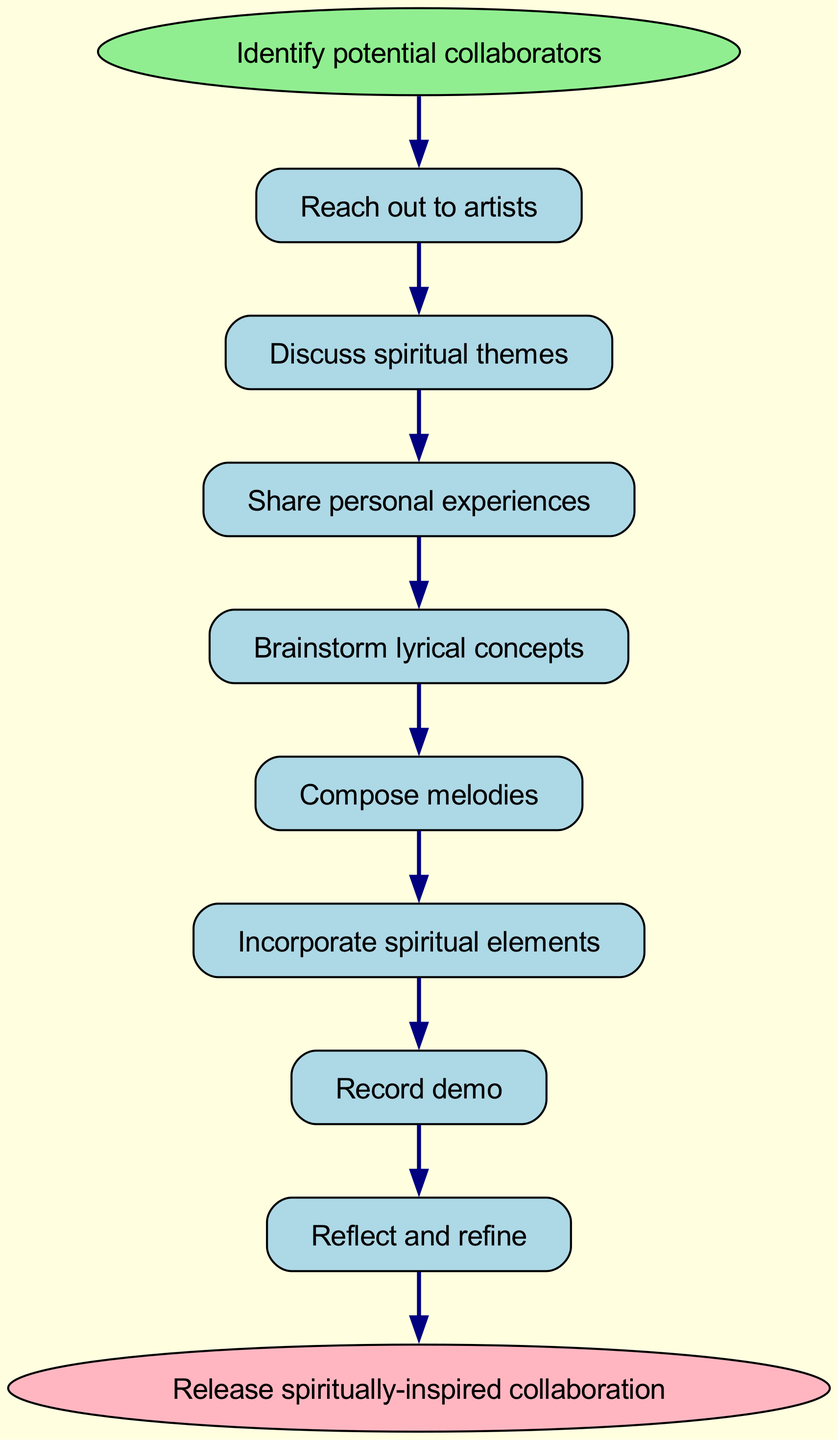What is the first step in the collaboration process? The flow chart starts with the node labeled "Identify potential collaborators," which indicates that this is the initial step in the process of collaborating on spiritually-inspired music projects.
Answer: Identify potential collaborators How many steps are there in the process? By counting each step in the flow chart, we see that there are eight distinct steps listed before the final endpoint of the collaboration.
Answer: Eight What is the last step in the collaboration process? The last step, as indicated in the flow chart, is "Release spiritually-inspired collaboration," which signifies the completion of the process.
Answer: Release spiritually-inspired collaboration Which step comes after "Brainstorm lyrical concepts"? In the flow chart, the next step after "Brainstorm lyrical concepts" is "Compose melodies," following the progression of the collaboration steps.
Answer: Compose melodies What two steps are connected directly by an edge after "Reflect and refine"? The flow chart shows that "Reflect and refine" is connected directly to "Final recording," indicating that these two steps occur sequentially.
Answer: Final recording Which step involves sharing personal experiences? The flow chart indicates that the step "Share personal experiences" is specifically dedicated to sharing individual insights and narratives, which is vital for a spiritually-inspired collaboration.
Answer: Share personal experiences In how many steps is the spiritual aspect incorporated into the process? The flow chart highlights that "Incorporate spiritual elements" is one distinct step, emphasizing the integration of spirituality within the overall collaboration process.
Answer: One What is the relationship between "Discuss spiritual themes" and "Share personal experiences"? The flow chart illustrates that "Discuss spiritual themes" precedes "Share personal experiences," showing a linear progression where themes are first discussed before personal narratives are shared.
Answer: Preceding step What is the purpose of the "Record demo" step? This step in the flow chart represents the phase where the actual recording of the musical collaboration occurs, serving as a foundational component before refining the project.
Answer: Actual recording 